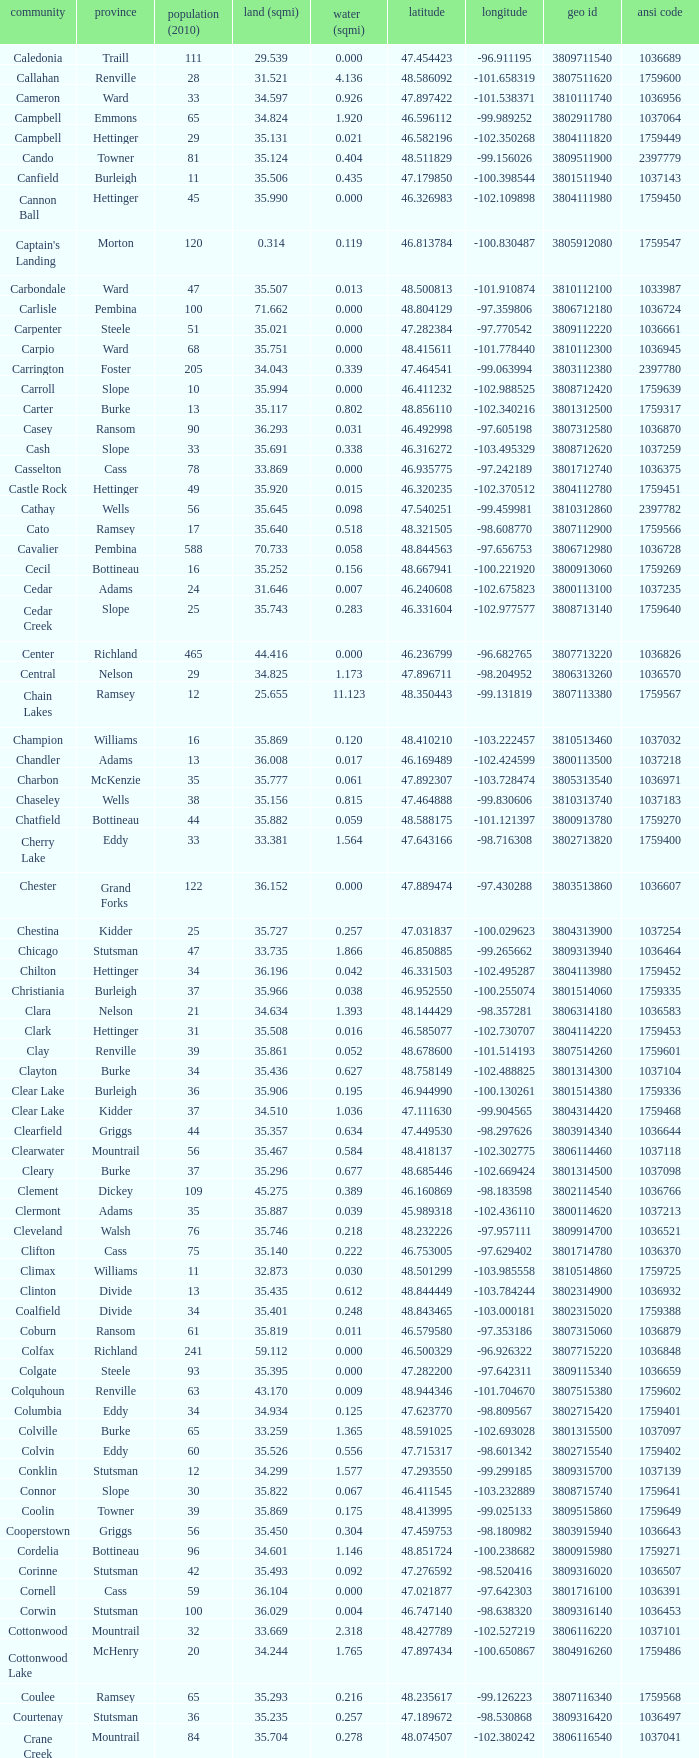What was the locality with a geo id of 3807116660? Creel. 